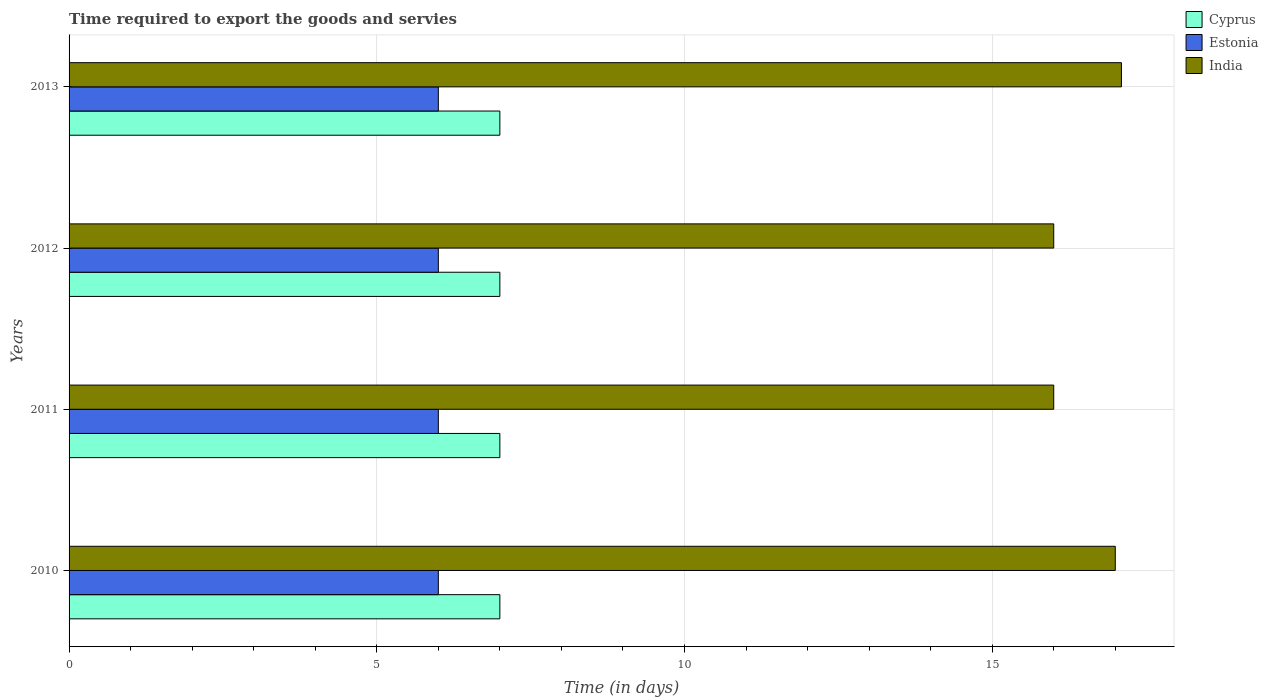How many bars are there on the 2nd tick from the top?
Ensure brevity in your answer.  3. In how many cases, is the number of bars for a given year not equal to the number of legend labels?
Keep it short and to the point. 0. Across all years, what is the minimum number of days required to export the goods and services in Estonia?
Your answer should be very brief. 6. In which year was the number of days required to export the goods and services in India maximum?
Your answer should be very brief. 2013. In which year was the number of days required to export the goods and services in Cyprus minimum?
Your answer should be compact. 2010. What is the total number of days required to export the goods and services in Estonia in the graph?
Provide a short and direct response. 24. What is the difference between the number of days required to export the goods and services in India in 2010 and the number of days required to export the goods and services in Estonia in 2013?
Keep it short and to the point. 11. What is the average number of days required to export the goods and services in Estonia per year?
Provide a succinct answer. 6. In the year 2013, what is the difference between the number of days required to export the goods and services in Cyprus and number of days required to export the goods and services in India?
Ensure brevity in your answer.  -10.1. What is the difference between the highest and the second highest number of days required to export the goods and services in India?
Offer a very short reply. 0.1. What is the difference between the highest and the lowest number of days required to export the goods and services in India?
Ensure brevity in your answer.  1.1. In how many years, is the number of days required to export the goods and services in India greater than the average number of days required to export the goods and services in India taken over all years?
Provide a succinct answer. 2. What does the 2nd bar from the top in 2010 represents?
Offer a terse response. Estonia. How many bars are there?
Provide a succinct answer. 12. Where does the legend appear in the graph?
Offer a very short reply. Top right. How many legend labels are there?
Make the answer very short. 3. How are the legend labels stacked?
Make the answer very short. Vertical. What is the title of the graph?
Ensure brevity in your answer.  Time required to export the goods and servies. What is the label or title of the X-axis?
Ensure brevity in your answer.  Time (in days). What is the Time (in days) of Cyprus in 2010?
Provide a succinct answer. 7. What is the Time (in days) in India in 2010?
Give a very brief answer. 17. What is the Time (in days) in Cyprus in 2011?
Your answer should be very brief. 7. What is the Time (in days) in Estonia in 2011?
Your answer should be very brief. 6. What is the Time (in days) of India in 2011?
Provide a short and direct response. 16. What is the Time (in days) of Estonia in 2012?
Make the answer very short. 6. What is the Time (in days) of India in 2012?
Keep it short and to the point. 16. What is the Time (in days) in Cyprus in 2013?
Your answer should be very brief. 7. What is the Time (in days) in Estonia in 2013?
Provide a succinct answer. 6. Across all years, what is the maximum Time (in days) of Estonia?
Your response must be concise. 6. Across all years, what is the maximum Time (in days) in India?
Your answer should be very brief. 17.1. Across all years, what is the minimum Time (in days) in India?
Provide a succinct answer. 16. What is the total Time (in days) of Cyprus in the graph?
Keep it short and to the point. 28. What is the total Time (in days) of Estonia in the graph?
Give a very brief answer. 24. What is the total Time (in days) of India in the graph?
Offer a terse response. 66.1. What is the difference between the Time (in days) of Cyprus in 2010 and that in 2011?
Offer a terse response. 0. What is the difference between the Time (in days) in Estonia in 2010 and that in 2011?
Provide a succinct answer. 0. What is the difference between the Time (in days) in India in 2011 and that in 2012?
Make the answer very short. 0. What is the difference between the Time (in days) of Cyprus in 2011 and that in 2013?
Keep it short and to the point. 0. What is the difference between the Time (in days) of Estonia in 2011 and that in 2013?
Keep it short and to the point. 0. What is the difference between the Time (in days) of India in 2011 and that in 2013?
Ensure brevity in your answer.  -1.1. What is the difference between the Time (in days) in India in 2012 and that in 2013?
Your answer should be very brief. -1.1. What is the difference between the Time (in days) in Cyprus in 2010 and the Time (in days) in India in 2011?
Make the answer very short. -9. What is the difference between the Time (in days) of Cyprus in 2010 and the Time (in days) of India in 2012?
Provide a succinct answer. -9. What is the difference between the Time (in days) in Cyprus in 2010 and the Time (in days) in Estonia in 2013?
Your response must be concise. 1. What is the difference between the Time (in days) in Estonia in 2011 and the Time (in days) in India in 2012?
Give a very brief answer. -10. What is the difference between the Time (in days) of Cyprus in 2011 and the Time (in days) of India in 2013?
Your response must be concise. -10.1. What is the difference between the Time (in days) of Cyprus in 2012 and the Time (in days) of Estonia in 2013?
Make the answer very short. 1. What is the difference between the Time (in days) of Estonia in 2012 and the Time (in days) of India in 2013?
Your response must be concise. -11.1. What is the average Time (in days) in Cyprus per year?
Provide a succinct answer. 7. What is the average Time (in days) of India per year?
Make the answer very short. 16.52. In the year 2010, what is the difference between the Time (in days) of Cyprus and Time (in days) of Estonia?
Your answer should be compact. 1. In the year 2010, what is the difference between the Time (in days) in Cyprus and Time (in days) in India?
Offer a very short reply. -10. In the year 2013, what is the difference between the Time (in days) in Estonia and Time (in days) in India?
Your answer should be very brief. -11.1. What is the ratio of the Time (in days) in Estonia in 2010 to that in 2011?
Make the answer very short. 1. What is the ratio of the Time (in days) in India in 2010 to that in 2011?
Your response must be concise. 1.06. What is the ratio of the Time (in days) of Estonia in 2010 to that in 2012?
Keep it short and to the point. 1. What is the ratio of the Time (in days) in India in 2010 to that in 2012?
Your answer should be compact. 1.06. What is the ratio of the Time (in days) in Cyprus in 2010 to that in 2013?
Provide a succinct answer. 1. What is the ratio of the Time (in days) in Estonia in 2010 to that in 2013?
Ensure brevity in your answer.  1. What is the ratio of the Time (in days) of Estonia in 2011 to that in 2012?
Your answer should be compact. 1. What is the ratio of the Time (in days) in India in 2011 to that in 2012?
Your answer should be very brief. 1. What is the ratio of the Time (in days) of Cyprus in 2011 to that in 2013?
Keep it short and to the point. 1. What is the ratio of the Time (in days) in India in 2011 to that in 2013?
Make the answer very short. 0.94. What is the ratio of the Time (in days) of Estonia in 2012 to that in 2013?
Your answer should be compact. 1. What is the ratio of the Time (in days) in India in 2012 to that in 2013?
Offer a very short reply. 0.94. What is the difference between the highest and the lowest Time (in days) of Cyprus?
Offer a terse response. 0. What is the difference between the highest and the lowest Time (in days) of Estonia?
Give a very brief answer. 0. What is the difference between the highest and the lowest Time (in days) in India?
Give a very brief answer. 1.1. 